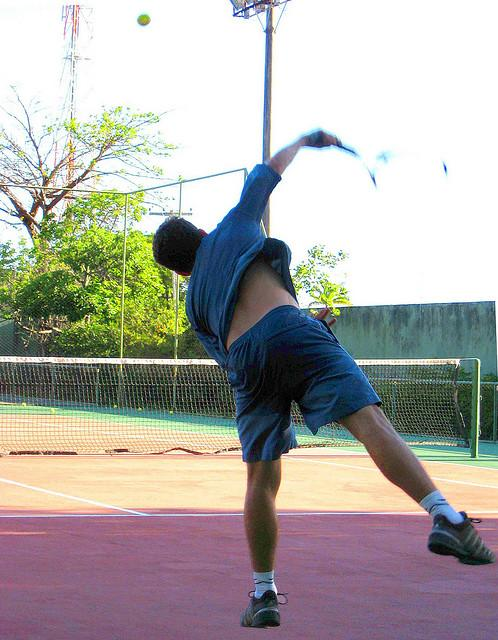What move has the player just used?

Choices:
A) lob
B) backhand
C) forehand
D) serve serve 